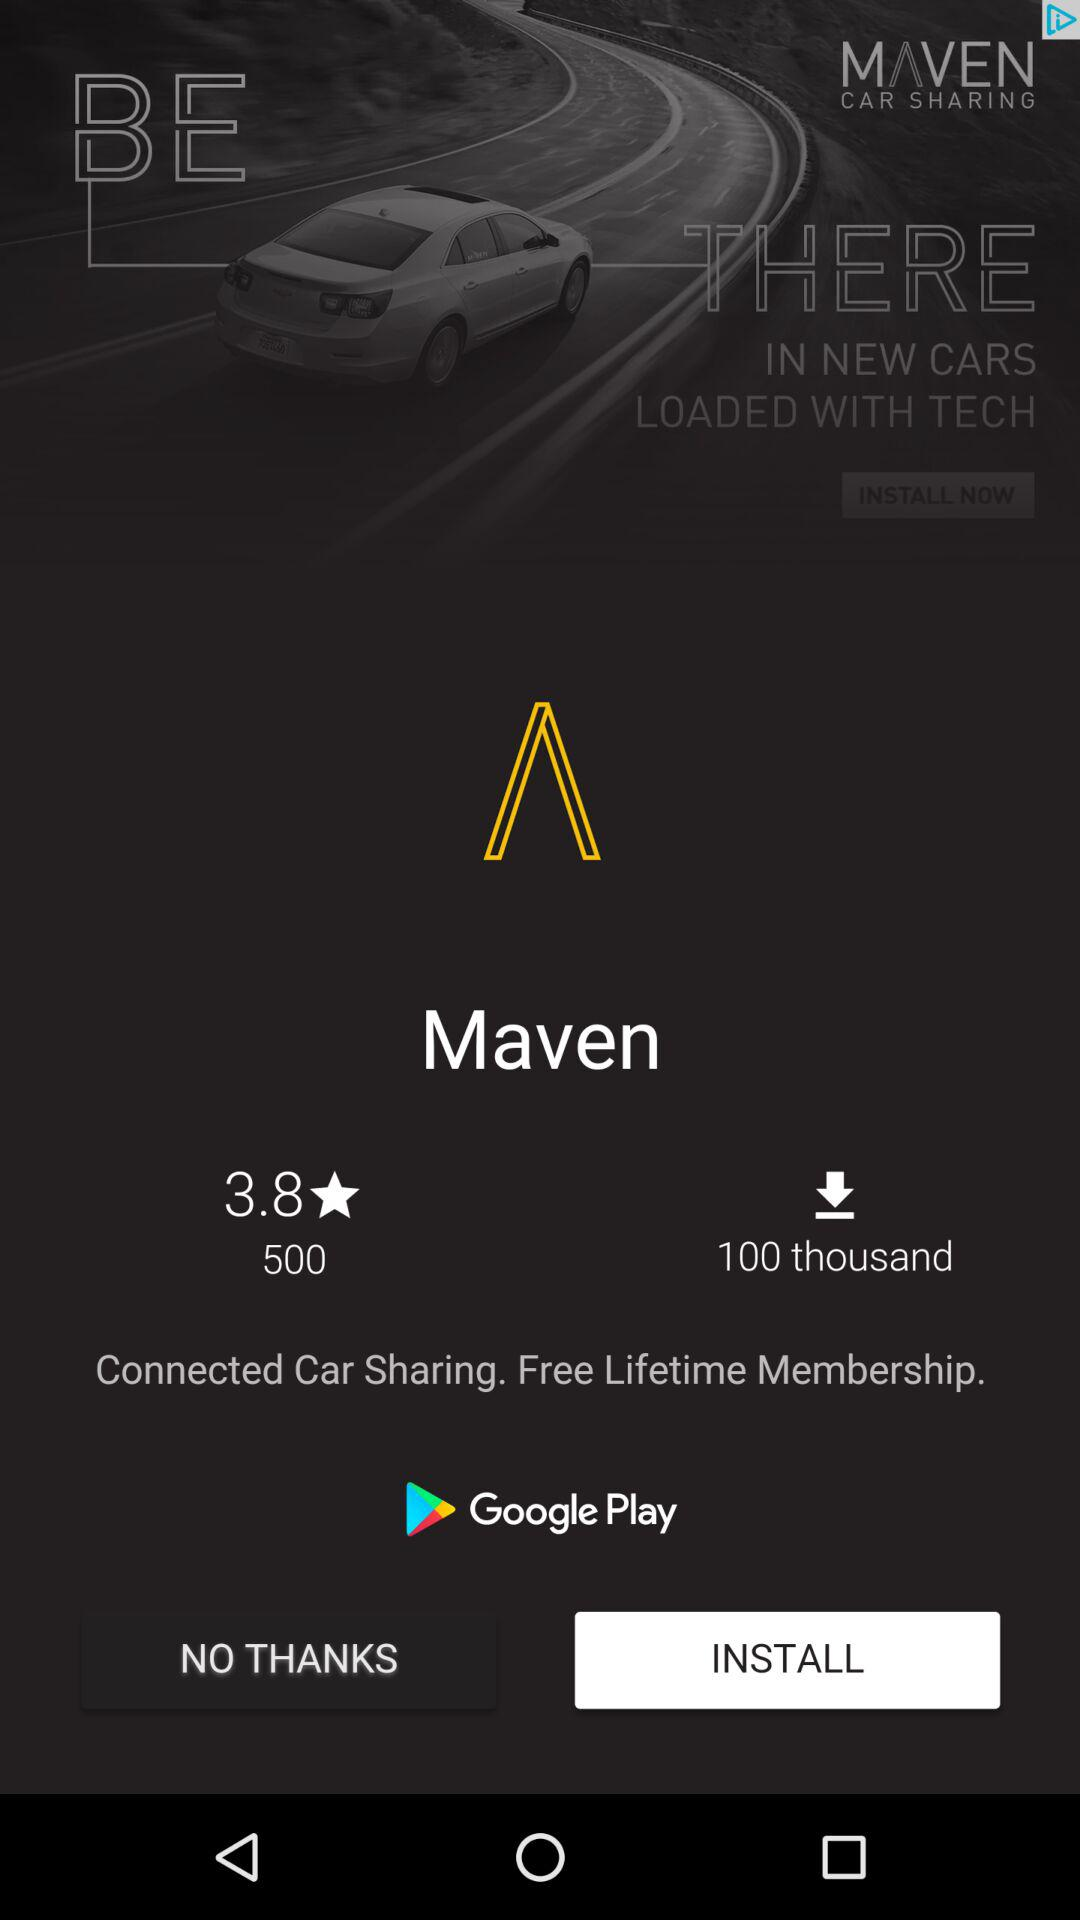How many downloads does the app have?
Answer the question using a single word or phrase. 100 thousand 